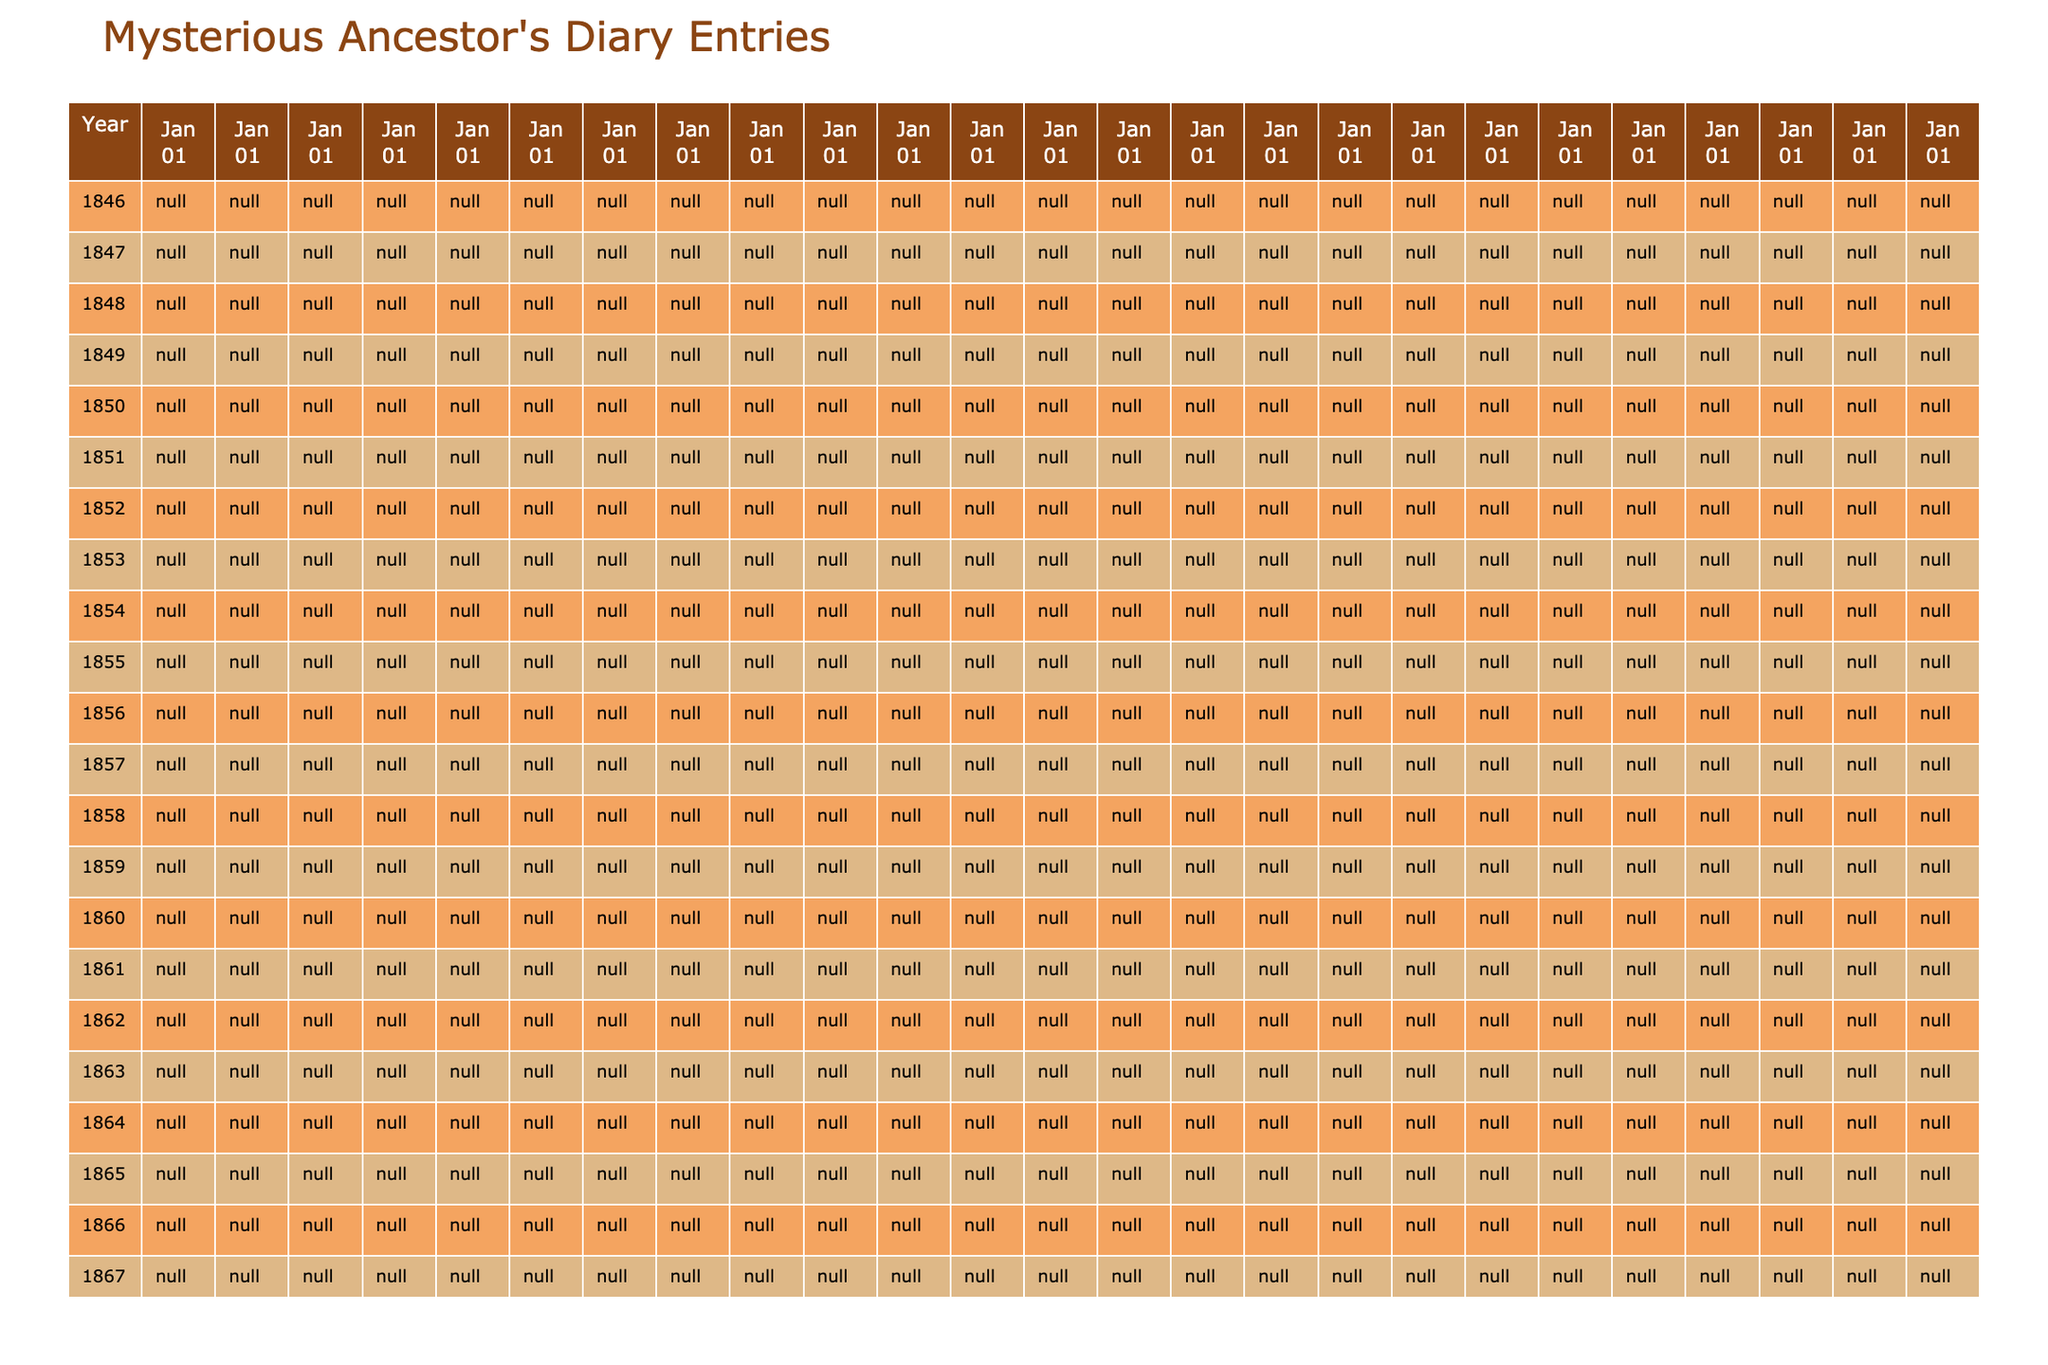What diary entry is from 1845? The table lists the diary entries chronologically. The entries from 1845 are on March 12 and June 19.
Answer: "Arrived in Boston harbor after long voyage. Must find work quickly." and "Met Elizabeth at the bakery. Her eyes remind me of home." What was the event recorded on June 19, 1845? By looking at the specified date in the table, it indicates that the event was meeting Elizabeth at the bakery.
Answer: Met Elizabeth at the bakery. Her eyes remind me of home How many entries mention gold? I can scan the entries for the word "gold." There are three entries that mention gold: January 3, 1846; February 14, 1847; and November 11, 1849.
Answer: 3 On what date did the author invest in a shipping company? The table shows that the author invested in a shipping company on March 1, 1854.
Answer: March 1, 1854 Did Elizabeth fall ill before the author's son was born? By examining the table, Elizabeth fell ill on June 30, 1857, while their son James was born on August 18, 1852. This means she fell ill after their son's birth.
Answer: No What was the first significant event recorded in the diary? The first date listed in the table is March 12, 1845, where the author arrived in Boston harbor. This is the first significant event recorded.
Answer: Arrived in Boston harbor after long voyage. Must find work quickly What was the author's emotional state after losing Elizabeth? Referring to the entry on February 22, 1858, the author expresses profound grief with the statement, "My beloved Elizabeth laid to rest. How shall I go on?"
Answer: Deep sorrow and grief How many years passed between the birth of James and the author's first Christmas in their new home? James was born on August 18, 1852, and the first Christmas in their new home was on December 25, 1851. Calculating the difference shows they are one year apart; thus, the answer is one year.
Answer: 1 year What repeated theme can be identified in the diary entries? Scanning through the entries reveals themes of significant life events such as love, loss, and the pursuit of fortune, particularly regarding gold and family.
Answer: Love, loss, and fortune What is the last entry recorded in the diary? According to the table, the last entry is dated January 1, 1870, where the author reflects on penning his story for his son.
Answer: January 1, 1870 